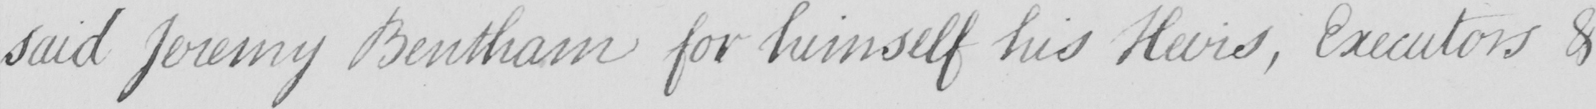Can you tell me what this handwritten text says? said Jeremy Bentham for himself his Heirs , Executors & 